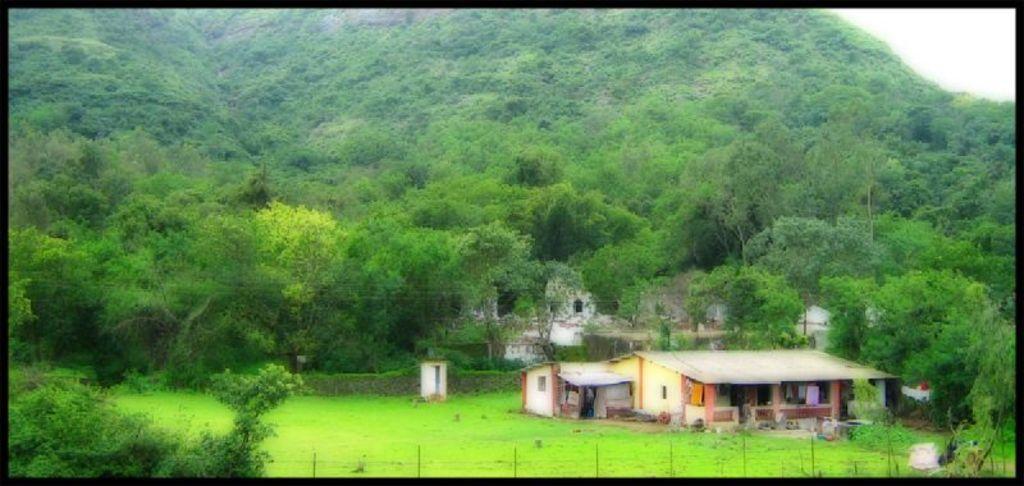In one or two sentences, can you explain what this image depicts? In this picture we can see houses, grass, plants, and trees. At the top of the picture we can see sky. 